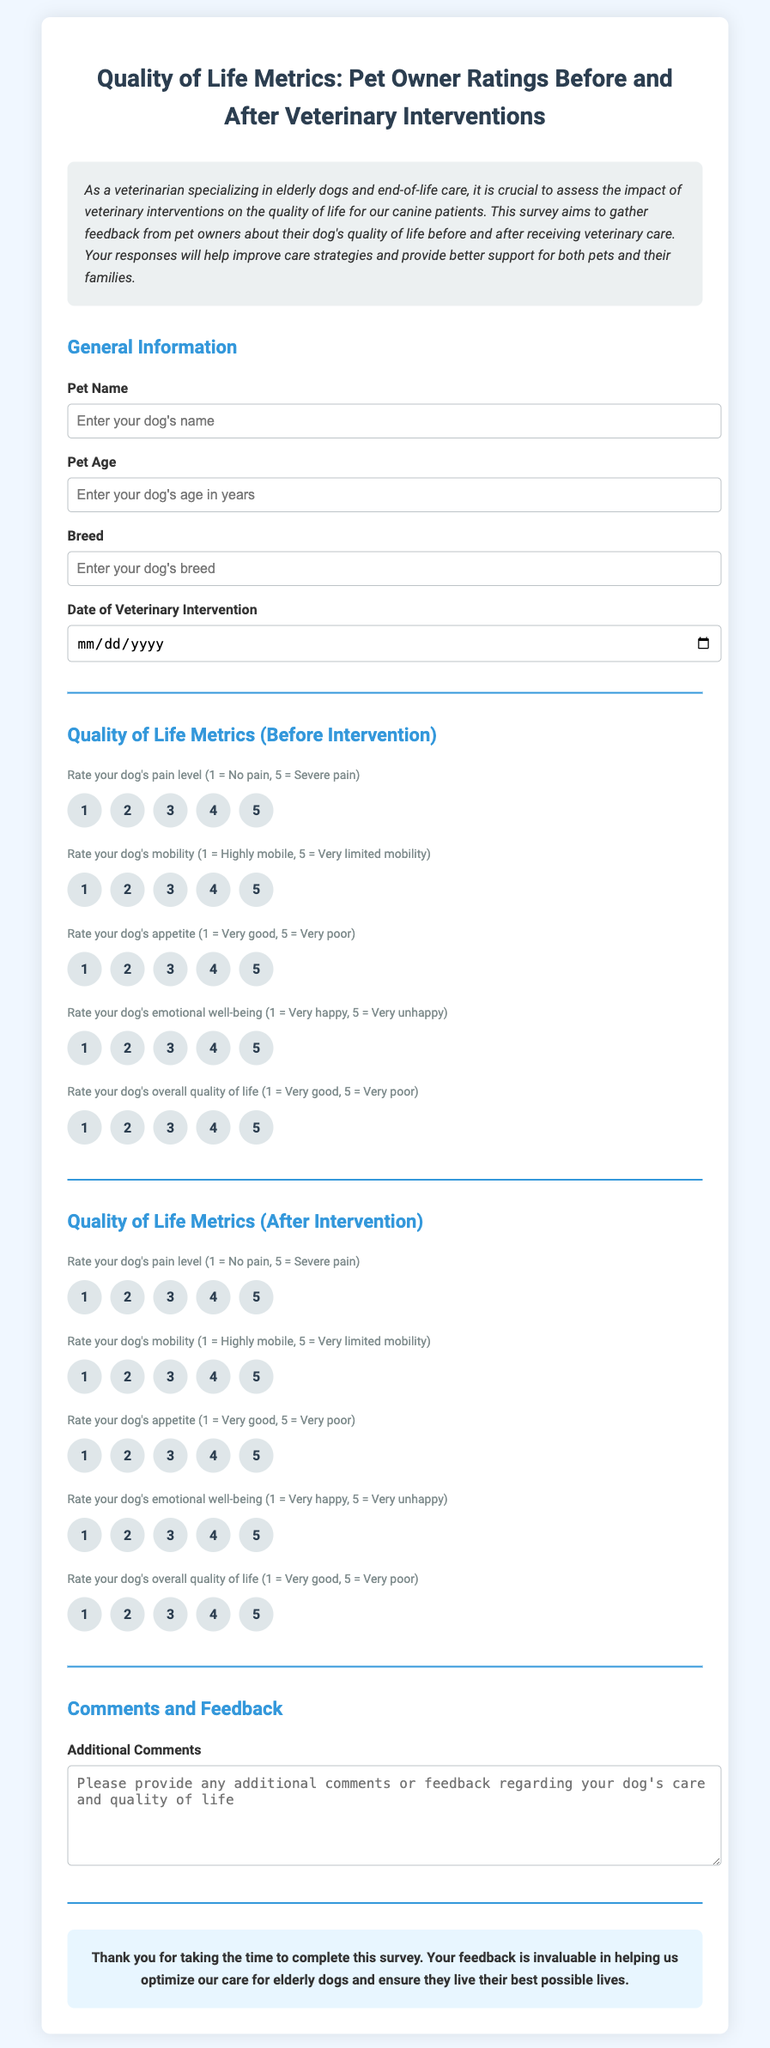What is the title of the document? The title is the main heading presented at the top of the document, indicating the survey's focus.
Answer: Quality of Life Metrics: Pet Owner Ratings Before and After Veterinary Interventions What type of animals is the survey focused on? The introduction specifies that the survey is aimed at pet owners of a specific category of animals.
Answer: Dogs What age is requested for the pet? The form includes a specific question about the age of the pet, which should be recorded in years.
Answer: Years What is being rated in the Quality of Life Metrics section? The metrics section includes various areas where pet owners are asked to rate their dogs before and after intervention.
Answer: Pain level, mobility, appetite, emotional well-being, overall quality of life How many quality of life metrics are listed for rating before intervention? The "Quality of Life Metrics (Before Intervention)" section asks for ratings in five specific areas.
Answer: Five What is the date format required for the veterinary intervention? The form requests a specific date format for entry, which is standard for such information.
Answer: Date What additional information is requested from respondents at the end of the survey? Respondents are encouraged to provide further thoughts in a designated section for feedback.
Answer: Additional Comments What color scheme is used for the document? The overall color palette is defined by the specific shades indicated in the style section of the document.
Answer: Light blue and white What type of questions does this document contain? The main purpose of this document is to gather subjective feedback related to veterinary care, which suggests a specific question format.
Answer: Rating scale questions 